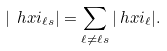Convert formula to latex. <formula><loc_0><loc_0><loc_500><loc_500>| \ h x i _ { \ell s } | & = \sum _ { \ell \neq \ell s } | \ h x i _ { \ell } | .</formula> 